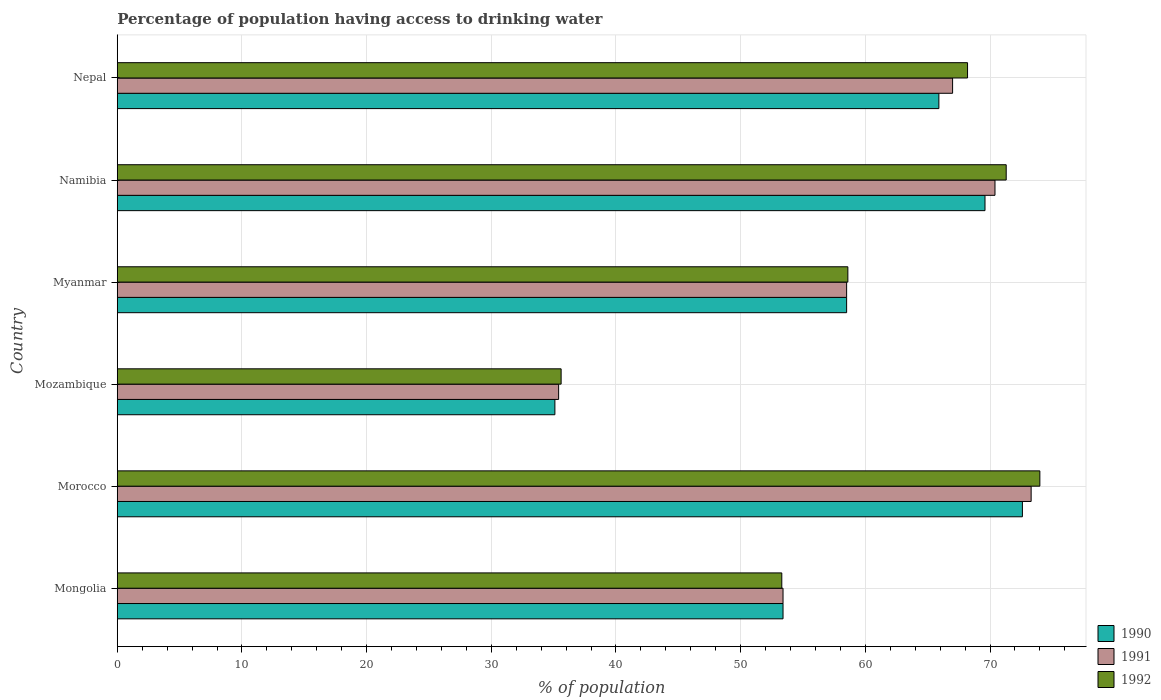How many groups of bars are there?
Give a very brief answer. 6. What is the label of the 4th group of bars from the top?
Offer a terse response. Mozambique. What is the percentage of population having access to drinking water in 1991 in Myanmar?
Give a very brief answer. 58.5. Across all countries, what is the minimum percentage of population having access to drinking water in 1991?
Offer a terse response. 35.4. In which country was the percentage of population having access to drinking water in 1991 maximum?
Your response must be concise. Morocco. In which country was the percentage of population having access to drinking water in 1992 minimum?
Your answer should be compact. Mozambique. What is the total percentage of population having access to drinking water in 1991 in the graph?
Offer a very short reply. 358. What is the difference between the percentage of population having access to drinking water in 1990 in Myanmar and that in Nepal?
Offer a very short reply. -7.4. What is the difference between the percentage of population having access to drinking water in 1992 in Myanmar and the percentage of population having access to drinking water in 1991 in Namibia?
Give a very brief answer. -11.8. What is the average percentage of population having access to drinking water in 1991 per country?
Provide a short and direct response. 59.67. What is the difference between the percentage of population having access to drinking water in 1991 and percentage of population having access to drinking water in 1990 in Namibia?
Ensure brevity in your answer.  0.8. In how many countries, is the percentage of population having access to drinking water in 1991 greater than 48 %?
Offer a terse response. 5. What is the ratio of the percentage of population having access to drinking water in 1990 in Mongolia to that in Morocco?
Offer a very short reply. 0.74. Is the percentage of population having access to drinking water in 1992 in Morocco less than that in Nepal?
Provide a short and direct response. No. What is the difference between the highest and the second highest percentage of population having access to drinking water in 1991?
Provide a short and direct response. 2.9. What is the difference between the highest and the lowest percentage of population having access to drinking water in 1990?
Make the answer very short. 37.5. Is the sum of the percentage of population having access to drinking water in 1992 in Morocco and Myanmar greater than the maximum percentage of population having access to drinking water in 1990 across all countries?
Provide a succinct answer. Yes. What does the 1st bar from the bottom in Myanmar represents?
Keep it short and to the point. 1990. Is it the case that in every country, the sum of the percentage of population having access to drinking water in 1990 and percentage of population having access to drinking water in 1991 is greater than the percentage of population having access to drinking water in 1992?
Your answer should be very brief. Yes. How many bars are there?
Offer a very short reply. 18. Are all the bars in the graph horizontal?
Give a very brief answer. Yes. Are the values on the major ticks of X-axis written in scientific E-notation?
Provide a succinct answer. No. Does the graph contain any zero values?
Your answer should be compact. No. Does the graph contain grids?
Provide a short and direct response. Yes. How many legend labels are there?
Offer a very short reply. 3. How are the legend labels stacked?
Your answer should be very brief. Vertical. What is the title of the graph?
Provide a short and direct response. Percentage of population having access to drinking water. Does "1997" appear as one of the legend labels in the graph?
Give a very brief answer. No. What is the label or title of the X-axis?
Keep it short and to the point. % of population. What is the label or title of the Y-axis?
Keep it short and to the point. Country. What is the % of population in 1990 in Mongolia?
Ensure brevity in your answer.  53.4. What is the % of population in 1991 in Mongolia?
Make the answer very short. 53.4. What is the % of population in 1992 in Mongolia?
Make the answer very short. 53.3. What is the % of population of 1990 in Morocco?
Your answer should be very brief. 72.6. What is the % of population in 1991 in Morocco?
Keep it short and to the point. 73.3. What is the % of population in 1990 in Mozambique?
Keep it short and to the point. 35.1. What is the % of population in 1991 in Mozambique?
Ensure brevity in your answer.  35.4. What is the % of population in 1992 in Mozambique?
Offer a very short reply. 35.6. What is the % of population in 1990 in Myanmar?
Your response must be concise. 58.5. What is the % of population of 1991 in Myanmar?
Your answer should be very brief. 58.5. What is the % of population in 1992 in Myanmar?
Make the answer very short. 58.6. What is the % of population of 1990 in Namibia?
Provide a succinct answer. 69.6. What is the % of population in 1991 in Namibia?
Provide a succinct answer. 70.4. What is the % of population in 1992 in Namibia?
Keep it short and to the point. 71.3. What is the % of population of 1990 in Nepal?
Your answer should be very brief. 65.9. What is the % of population in 1991 in Nepal?
Your answer should be compact. 67. What is the % of population of 1992 in Nepal?
Make the answer very short. 68.2. Across all countries, what is the maximum % of population of 1990?
Ensure brevity in your answer.  72.6. Across all countries, what is the maximum % of population of 1991?
Ensure brevity in your answer.  73.3. Across all countries, what is the maximum % of population of 1992?
Your response must be concise. 74. Across all countries, what is the minimum % of population of 1990?
Offer a terse response. 35.1. Across all countries, what is the minimum % of population in 1991?
Provide a succinct answer. 35.4. Across all countries, what is the minimum % of population in 1992?
Provide a short and direct response. 35.6. What is the total % of population of 1990 in the graph?
Provide a short and direct response. 355.1. What is the total % of population in 1991 in the graph?
Keep it short and to the point. 358. What is the total % of population in 1992 in the graph?
Give a very brief answer. 361. What is the difference between the % of population in 1990 in Mongolia and that in Morocco?
Your response must be concise. -19.2. What is the difference between the % of population of 1991 in Mongolia and that in Morocco?
Provide a short and direct response. -19.9. What is the difference between the % of population of 1992 in Mongolia and that in Morocco?
Your answer should be compact. -20.7. What is the difference between the % of population of 1991 in Mongolia and that in Mozambique?
Your answer should be compact. 18. What is the difference between the % of population in 1992 in Mongolia and that in Mozambique?
Offer a terse response. 17.7. What is the difference between the % of population in 1991 in Mongolia and that in Myanmar?
Provide a succinct answer. -5.1. What is the difference between the % of population of 1990 in Mongolia and that in Namibia?
Your answer should be very brief. -16.2. What is the difference between the % of population in 1991 in Mongolia and that in Namibia?
Keep it short and to the point. -17. What is the difference between the % of population in 1992 in Mongolia and that in Namibia?
Offer a terse response. -18. What is the difference between the % of population of 1990 in Mongolia and that in Nepal?
Provide a succinct answer. -12.5. What is the difference between the % of population in 1992 in Mongolia and that in Nepal?
Offer a very short reply. -14.9. What is the difference between the % of population in 1990 in Morocco and that in Mozambique?
Your answer should be very brief. 37.5. What is the difference between the % of population in 1991 in Morocco and that in Mozambique?
Give a very brief answer. 37.9. What is the difference between the % of population of 1992 in Morocco and that in Mozambique?
Provide a short and direct response. 38.4. What is the difference between the % of population of 1992 in Morocco and that in Myanmar?
Ensure brevity in your answer.  15.4. What is the difference between the % of population in 1990 in Morocco and that in Namibia?
Give a very brief answer. 3. What is the difference between the % of population in 1990 in Morocco and that in Nepal?
Make the answer very short. 6.7. What is the difference between the % of population in 1991 in Morocco and that in Nepal?
Give a very brief answer. 6.3. What is the difference between the % of population in 1990 in Mozambique and that in Myanmar?
Make the answer very short. -23.4. What is the difference between the % of population in 1991 in Mozambique and that in Myanmar?
Provide a short and direct response. -23.1. What is the difference between the % of population in 1992 in Mozambique and that in Myanmar?
Give a very brief answer. -23. What is the difference between the % of population of 1990 in Mozambique and that in Namibia?
Your answer should be very brief. -34.5. What is the difference between the % of population in 1991 in Mozambique and that in Namibia?
Offer a terse response. -35. What is the difference between the % of population in 1992 in Mozambique and that in Namibia?
Make the answer very short. -35.7. What is the difference between the % of population in 1990 in Mozambique and that in Nepal?
Your response must be concise. -30.8. What is the difference between the % of population in 1991 in Mozambique and that in Nepal?
Offer a terse response. -31.6. What is the difference between the % of population in 1992 in Mozambique and that in Nepal?
Make the answer very short. -32.6. What is the difference between the % of population in 1990 in Myanmar and that in Namibia?
Provide a succinct answer. -11.1. What is the difference between the % of population in 1991 in Myanmar and that in Namibia?
Give a very brief answer. -11.9. What is the difference between the % of population of 1990 in Myanmar and that in Nepal?
Provide a short and direct response. -7.4. What is the difference between the % of population in 1992 in Myanmar and that in Nepal?
Your answer should be compact. -9.6. What is the difference between the % of population in 1990 in Namibia and that in Nepal?
Provide a short and direct response. 3.7. What is the difference between the % of population in 1992 in Namibia and that in Nepal?
Keep it short and to the point. 3.1. What is the difference between the % of population of 1990 in Mongolia and the % of population of 1991 in Morocco?
Your answer should be very brief. -19.9. What is the difference between the % of population of 1990 in Mongolia and the % of population of 1992 in Morocco?
Provide a short and direct response. -20.6. What is the difference between the % of population in 1991 in Mongolia and the % of population in 1992 in Morocco?
Keep it short and to the point. -20.6. What is the difference between the % of population of 1990 in Mongolia and the % of population of 1991 in Mozambique?
Ensure brevity in your answer.  18. What is the difference between the % of population in 1991 in Mongolia and the % of population in 1992 in Mozambique?
Provide a short and direct response. 17.8. What is the difference between the % of population in 1990 in Mongolia and the % of population in 1991 in Myanmar?
Ensure brevity in your answer.  -5.1. What is the difference between the % of population in 1990 in Mongolia and the % of population in 1991 in Namibia?
Provide a short and direct response. -17. What is the difference between the % of population in 1990 in Mongolia and the % of population in 1992 in Namibia?
Offer a very short reply. -17.9. What is the difference between the % of population of 1991 in Mongolia and the % of population of 1992 in Namibia?
Offer a terse response. -17.9. What is the difference between the % of population in 1990 in Mongolia and the % of population in 1991 in Nepal?
Provide a short and direct response. -13.6. What is the difference between the % of population of 1990 in Mongolia and the % of population of 1992 in Nepal?
Make the answer very short. -14.8. What is the difference between the % of population of 1991 in Mongolia and the % of population of 1992 in Nepal?
Keep it short and to the point. -14.8. What is the difference between the % of population of 1990 in Morocco and the % of population of 1991 in Mozambique?
Your response must be concise. 37.2. What is the difference between the % of population in 1990 in Morocco and the % of population in 1992 in Mozambique?
Offer a very short reply. 37. What is the difference between the % of population of 1991 in Morocco and the % of population of 1992 in Mozambique?
Your answer should be compact. 37.7. What is the difference between the % of population of 1990 in Morocco and the % of population of 1992 in Myanmar?
Offer a very short reply. 14. What is the difference between the % of population of 1990 in Morocco and the % of population of 1991 in Namibia?
Provide a succinct answer. 2.2. What is the difference between the % of population of 1990 in Morocco and the % of population of 1992 in Nepal?
Offer a terse response. 4.4. What is the difference between the % of population in 1991 in Morocco and the % of population in 1992 in Nepal?
Your answer should be very brief. 5.1. What is the difference between the % of population in 1990 in Mozambique and the % of population in 1991 in Myanmar?
Provide a succinct answer. -23.4. What is the difference between the % of population in 1990 in Mozambique and the % of population in 1992 in Myanmar?
Your answer should be very brief. -23.5. What is the difference between the % of population in 1991 in Mozambique and the % of population in 1992 in Myanmar?
Provide a succinct answer. -23.2. What is the difference between the % of population in 1990 in Mozambique and the % of population in 1991 in Namibia?
Give a very brief answer. -35.3. What is the difference between the % of population of 1990 in Mozambique and the % of population of 1992 in Namibia?
Your answer should be compact. -36.2. What is the difference between the % of population of 1991 in Mozambique and the % of population of 1992 in Namibia?
Your answer should be compact. -35.9. What is the difference between the % of population in 1990 in Mozambique and the % of population in 1991 in Nepal?
Your answer should be very brief. -31.9. What is the difference between the % of population in 1990 in Mozambique and the % of population in 1992 in Nepal?
Your response must be concise. -33.1. What is the difference between the % of population in 1991 in Mozambique and the % of population in 1992 in Nepal?
Offer a terse response. -32.8. What is the difference between the % of population in 1990 in Myanmar and the % of population in 1992 in Nepal?
Provide a succinct answer. -9.7. What is the difference between the % of population in 1991 in Myanmar and the % of population in 1992 in Nepal?
Keep it short and to the point. -9.7. What is the difference between the % of population of 1991 in Namibia and the % of population of 1992 in Nepal?
Your answer should be very brief. 2.2. What is the average % of population of 1990 per country?
Provide a succinct answer. 59.18. What is the average % of population in 1991 per country?
Ensure brevity in your answer.  59.67. What is the average % of population in 1992 per country?
Keep it short and to the point. 60.17. What is the difference between the % of population of 1990 and % of population of 1992 in Morocco?
Make the answer very short. -1.4. What is the difference between the % of population in 1991 and % of population in 1992 in Morocco?
Offer a terse response. -0.7. What is the difference between the % of population of 1990 and % of population of 1992 in Mozambique?
Provide a succinct answer. -0.5. What is the difference between the % of population in 1991 and % of population in 1992 in Mozambique?
Offer a very short reply. -0.2. What is the difference between the % of population of 1990 and % of population of 1991 in Myanmar?
Offer a terse response. 0. What is the difference between the % of population of 1991 and % of population of 1992 in Myanmar?
Your response must be concise. -0.1. What is the difference between the % of population in 1990 and % of population in 1992 in Namibia?
Ensure brevity in your answer.  -1.7. What is the difference between the % of population in 1991 and % of population in 1992 in Namibia?
Your answer should be compact. -0.9. What is the difference between the % of population in 1990 and % of population in 1991 in Nepal?
Give a very brief answer. -1.1. What is the ratio of the % of population in 1990 in Mongolia to that in Morocco?
Offer a terse response. 0.74. What is the ratio of the % of population in 1991 in Mongolia to that in Morocco?
Offer a very short reply. 0.73. What is the ratio of the % of population in 1992 in Mongolia to that in Morocco?
Provide a succinct answer. 0.72. What is the ratio of the % of population in 1990 in Mongolia to that in Mozambique?
Provide a succinct answer. 1.52. What is the ratio of the % of population in 1991 in Mongolia to that in Mozambique?
Offer a very short reply. 1.51. What is the ratio of the % of population of 1992 in Mongolia to that in Mozambique?
Provide a short and direct response. 1.5. What is the ratio of the % of population of 1990 in Mongolia to that in Myanmar?
Offer a terse response. 0.91. What is the ratio of the % of population in 1991 in Mongolia to that in Myanmar?
Give a very brief answer. 0.91. What is the ratio of the % of population of 1992 in Mongolia to that in Myanmar?
Ensure brevity in your answer.  0.91. What is the ratio of the % of population of 1990 in Mongolia to that in Namibia?
Provide a succinct answer. 0.77. What is the ratio of the % of population of 1991 in Mongolia to that in Namibia?
Make the answer very short. 0.76. What is the ratio of the % of population of 1992 in Mongolia to that in Namibia?
Your answer should be very brief. 0.75. What is the ratio of the % of population of 1990 in Mongolia to that in Nepal?
Make the answer very short. 0.81. What is the ratio of the % of population in 1991 in Mongolia to that in Nepal?
Offer a terse response. 0.8. What is the ratio of the % of population in 1992 in Mongolia to that in Nepal?
Keep it short and to the point. 0.78. What is the ratio of the % of population in 1990 in Morocco to that in Mozambique?
Your answer should be very brief. 2.07. What is the ratio of the % of population in 1991 in Morocco to that in Mozambique?
Provide a short and direct response. 2.07. What is the ratio of the % of population in 1992 in Morocco to that in Mozambique?
Make the answer very short. 2.08. What is the ratio of the % of population in 1990 in Morocco to that in Myanmar?
Make the answer very short. 1.24. What is the ratio of the % of population in 1991 in Morocco to that in Myanmar?
Give a very brief answer. 1.25. What is the ratio of the % of population of 1992 in Morocco to that in Myanmar?
Ensure brevity in your answer.  1.26. What is the ratio of the % of population of 1990 in Morocco to that in Namibia?
Make the answer very short. 1.04. What is the ratio of the % of population in 1991 in Morocco to that in Namibia?
Your answer should be very brief. 1.04. What is the ratio of the % of population of 1992 in Morocco to that in Namibia?
Give a very brief answer. 1.04. What is the ratio of the % of population in 1990 in Morocco to that in Nepal?
Ensure brevity in your answer.  1.1. What is the ratio of the % of population in 1991 in Morocco to that in Nepal?
Your response must be concise. 1.09. What is the ratio of the % of population of 1992 in Morocco to that in Nepal?
Give a very brief answer. 1.08. What is the ratio of the % of population in 1990 in Mozambique to that in Myanmar?
Ensure brevity in your answer.  0.6. What is the ratio of the % of population of 1991 in Mozambique to that in Myanmar?
Provide a succinct answer. 0.61. What is the ratio of the % of population of 1992 in Mozambique to that in Myanmar?
Provide a short and direct response. 0.61. What is the ratio of the % of population in 1990 in Mozambique to that in Namibia?
Provide a succinct answer. 0.5. What is the ratio of the % of population of 1991 in Mozambique to that in Namibia?
Provide a succinct answer. 0.5. What is the ratio of the % of population in 1992 in Mozambique to that in Namibia?
Keep it short and to the point. 0.5. What is the ratio of the % of population of 1990 in Mozambique to that in Nepal?
Provide a succinct answer. 0.53. What is the ratio of the % of population of 1991 in Mozambique to that in Nepal?
Provide a short and direct response. 0.53. What is the ratio of the % of population in 1992 in Mozambique to that in Nepal?
Your answer should be compact. 0.52. What is the ratio of the % of population in 1990 in Myanmar to that in Namibia?
Provide a short and direct response. 0.84. What is the ratio of the % of population of 1991 in Myanmar to that in Namibia?
Make the answer very short. 0.83. What is the ratio of the % of population of 1992 in Myanmar to that in Namibia?
Provide a succinct answer. 0.82. What is the ratio of the % of population of 1990 in Myanmar to that in Nepal?
Keep it short and to the point. 0.89. What is the ratio of the % of population of 1991 in Myanmar to that in Nepal?
Provide a succinct answer. 0.87. What is the ratio of the % of population in 1992 in Myanmar to that in Nepal?
Provide a succinct answer. 0.86. What is the ratio of the % of population of 1990 in Namibia to that in Nepal?
Offer a very short reply. 1.06. What is the ratio of the % of population in 1991 in Namibia to that in Nepal?
Your response must be concise. 1.05. What is the ratio of the % of population of 1992 in Namibia to that in Nepal?
Offer a very short reply. 1.05. What is the difference between the highest and the second highest % of population of 1990?
Offer a terse response. 3. What is the difference between the highest and the lowest % of population of 1990?
Offer a very short reply. 37.5. What is the difference between the highest and the lowest % of population in 1991?
Provide a succinct answer. 37.9. What is the difference between the highest and the lowest % of population in 1992?
Offer a very short reply. 38.4. 